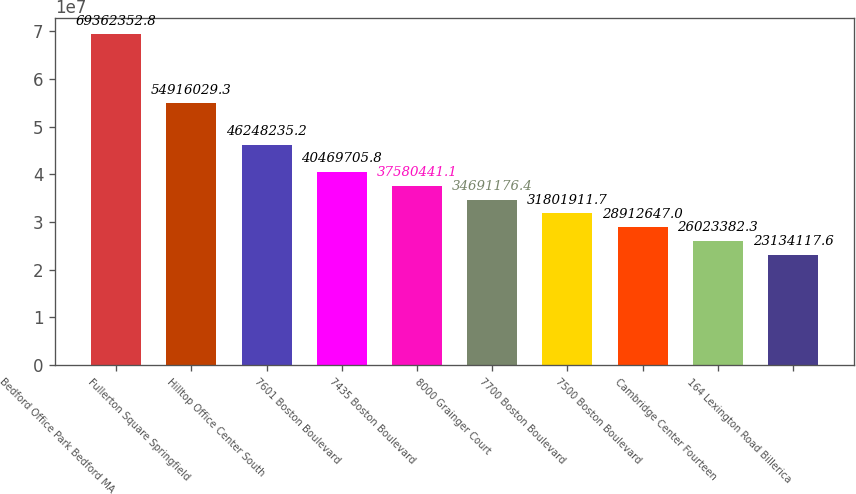Convert chart to OTSL. <chart><loc_0><loc_0><loc_500><loc_500><bar_chart><fcel>Bedford Office Park Bedford MA<fcel>Fullerton Square Springfield<fcel>Hilltop Office Center South<fcel>7601 Boston Boulevard<fcel>7435 Boston Boulevard<fcel>8000 Grainger Court<fcel>7700 Boston Boulevard<fcel>7500 Boston Boulevard<fcel>Cambridge Center Fourteen<fcel>164 Lexington Road Billerica<nl><fcel>6.93624e+07<fcel>5.4916e+07<fcel>4.62482e+07<fcel>4.04697e+07<fcel>3.75804e+07<fcel>3.46912e+07<fcel>3.18019e+07<fcel>2.89126e+07<fcel>2.60234e+07<fcel>2.31341e+07<nl></chart> 